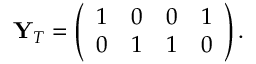<formula> <loc_0><loc_0><loc_500><loc_500>Y _ { T } = \left ( \begin{array} { c c c c } { 1 } & { 0 } & { 0 } & { 1 } \\ { 0 } & { 1 } & { 1 } & { 0 } \end{array} \right ) .</formula> 